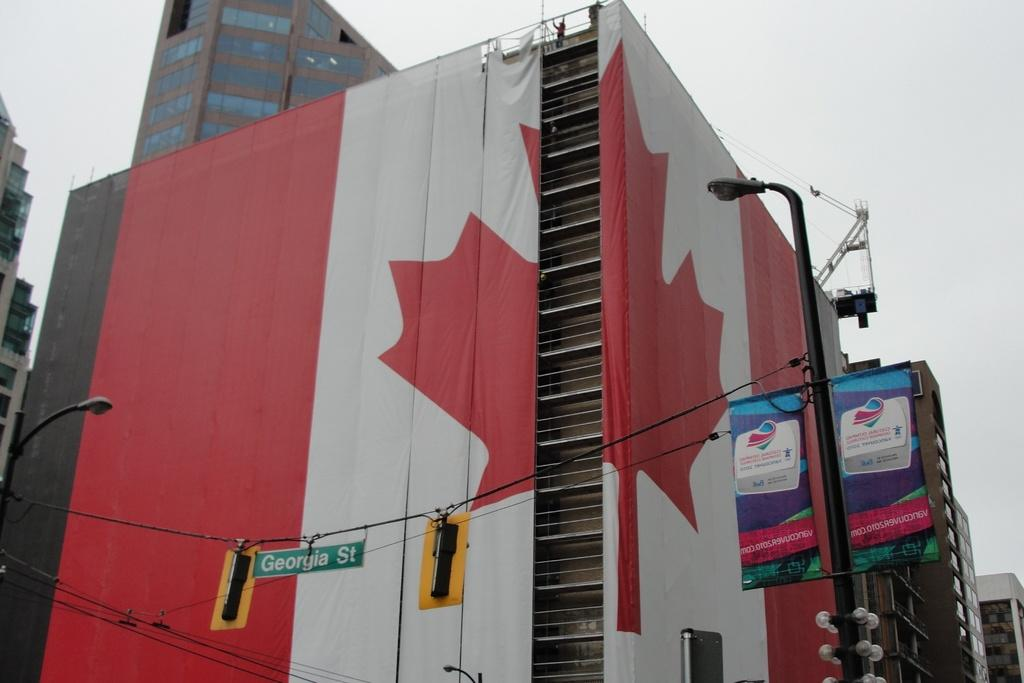<image>
Present a compact description of the photo's key features. A large Canadian flag which has a sign reading George Street in front. 